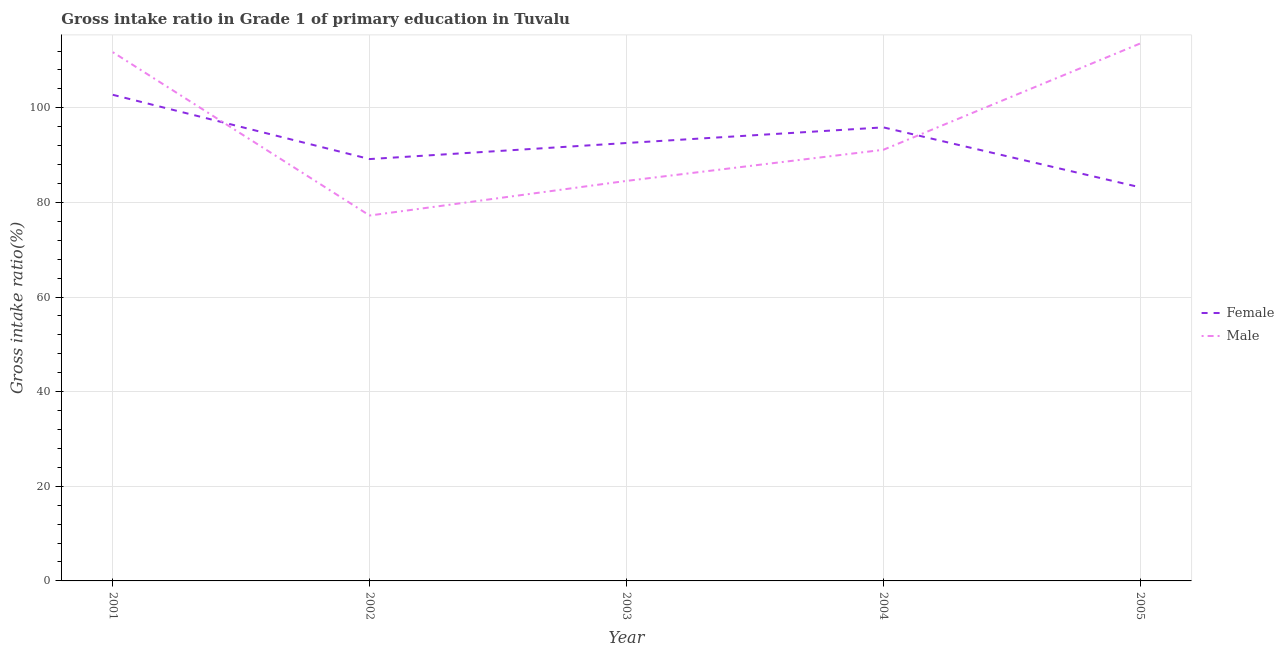How many different coloured lines are there?
Offer a very short reply. 2. Is the number of lines equal to the number of legend labels?
Keep it short and to the point. Yes. What is the gross intake ratio(female) in 2004?
Keep it short and to the point. 95.87. Across all years, what is the maximum gross intake ratio(female)?
Keep it short and to the point. 102.75. Across all years, what is the minimum gross intake ratio(female)?
Ensure brevity in your answer.  83.19. In which year was the gross intake ratio(male) maximum?
Give a very brief answer. 2005. In which year was the gross intake ratio(female) minimum?
Provide a succinct answer. 2005. What is the total gross intake ratio(male) in the graph?
Your answer should be compact. 478.28. What is the difference between the gross intake ratio(male) in 2001 and that in 2004?
Make the answer very short. 20.64. What is the difference between the gross intake ratio(male) in 2003 and the gross intake ratio(female) in 2002?
Keep it short and to the point. -4.61. What is the average gross intake ratio(female) per year?
Provide a succinct answer. 92.71. In the year 2005, what is the difference between the gross intake ratio(male) and gross intake ratio(female)?
Give a very brief answer. 30.41. What is the ratio of the gross intake ratio(female) in 2002 to that in 2003?
Your answer should be very brief. 0.96. Is the gross intake ratio(female) in 2002 less than that in 2003?
Your answer should be very brief. Yes. Is the difference between the gross intake ratio(male) in 2003 and 2004 greater than the difference between the gross intake ratio(female) in 2003 and 2004?
Make the answer very short. No. What is the difference between the highest and the second highest gross intake ratio(male)?
Provide a short and direct response. 1.84. What is the difference between the highest and the lowest gross intake ratio(male)?
Ensure brevity in your answer.  36.36. Is the sum of the gross intake ratio(female) in 2003 and 2005 greater than the maximum gross intake ratio(male) across all years?
Make the answer very short. Yes. Is the gross intake ratio(female) strictly greater than the gross intake ratio(male) over the years?
Keep it short and to the point. No. What is the difference between two consecutive major ticks on the Y-axis?
Keep it short and to the point. 20. Are the values on the major ticks of Y-axis written in scientific E-notation?
Give a very brief answer. No. Does the graph contain grids?
Make the answer very short. Yes. How many legend labels are there?
Provide a short and direct response. 2. What is the title of the graph?
Ensure brevity in your answer.  Gross intake ratio in Grade 1 of primary education in Tuvalu. Does "Merchandise exports" appear as one of the legend labels in the graph?
Offer a terse response. No. What is the label or title of the Y-axis?
Offer a terse response. Gross intake ratio(%). What is the Gross intake ratio(%) of Female in 2001?
Offer a very short reply. 102.75. What is the Gross intake ratio(%) of Male in 2001?
Keep it short and to the point. 111.76. What is the Gross intake ratio(%) of Female in 2002?
Your answer should be compact. 89.17. What is the Gross intake ratio(%) in Male in 2002?
Give a very brief answer. 77.24. What is the Gross intake ratio(%) in Female in 2003?
Offer a very short reply. 92.56. What is the Gross intake ratio(%) of Male in 2003?
Provide a succinct answer. 84.55. What is the Gross intake ratio(%) in Female in 2004?
Ensure brevity in your answer.  95.87. What is the Gross intake ratio(%) of Male in 2004?
Ensure brevity in your answer.  91.13. What is the Gross intake ratio(%) of Female in 2005?
Offer a very short reply. 83.19. What is the Gross intake ratio(%) in Male in 2005?
Your answer should be compact. 113.6. Across all years, what is the maximum Gross intake ratio(%) of Female?
Make the answer very short. 102.75. Across all years, what is the maximum Gross intake ratio(%) of Male?
Make the answer very short. 113.6. Across all years, what is the minimum Gross intake ratio(%) in Female?
Give a very brief answer. 83.19. Across all years, what is the minimum Gross intake ratio(%) of Male?
Provide a short and direct response. 77.24. What is the total Gross intake ratio(%) of Female in the graph?
Your answer should be compact. 463.54. What is the total Gross intake ratio(%) in Male in the graph?
Ensure brevity in your answer.  478.28. What is the difference between the Gross intake ratio(%) of Female in 2001 and that in 2002?
Make the answer very short. 13.59. What is the difference between the Gross intake ratio(%) of Male in 2001 and that in 2002?
Make the answer very short. 34.53. What is the difference between the Gross intake ratio(%) in Female in 2001 and that in 2003?
Provide a short and direct response. 10.19. What is the difference between the Gross intake ratio(%) in Male in 2001 and that in 2003?
Your response must be concise. 27.21. What is the difference between the Gross intake ratio(%) in Female in 2001 and that in 2004?
Ensure brevity in your answer.  6.88. What is the difference between the Gross intake ratio(%) in Male in 2001 and that in 2004?
Offer a terse response. 20.64. What is the difference between the Gross intake ratio(%) in Female in 2001 and that in 2005?
Make the answer very short. 19.56. What is the difference between the Gross intake ratio(%) of Male in 2001 and that in 2005?
Provide a succinct answer. -1.84. What is the difference between the Gross intake ratio(%) in Female in 2002 and that in 2003?
Provide a succinct answer. -3.4. What is the difference between the Gross intake ratio(%) of Male in 2002 and that in 2003?
Provide a short and direct response. -7.32. What is the difference between the Gross intake ratio(%) of Female in 2002 and that in 2004?
Provide a succinct answer. -6.7. What is the difference between the Gross intake ratio(%) of Male in 2002 and that in 2004?
Your answer should be compact. -13.89. What is the difference between the Gross intake ratio(%) in Female in 2002 and that in 2005?
Your answer should be very brief. 5.97. What is the difference between the Gross intake ratio(%) of Male in 2002 and that in 2005?
Keep it short and to the point. -36.36. What is the difference between the Gross intake ratio(%) in Female in 2003 and that in 2004?
Ensure brevity in your answer.  -3.31. What is the difference between the Gross intake ratio(%) of Male in 2003 and that in 2004?
Provide a succinct answer. -6.58. What is the difference between the Gross intake ratio(%) in Female in 2003 and that in 2005?
Keep it short and to the point. 9.37. What is the difference between the Gross intake ratio(%) in Male in 2003 and that in 2005?
Offer a terse response. -29.05. What is the difference between the Gross intake ratio(%) in Female in 2004 and that in 2005?
Offer a terse response. 12.67. What is the difference between the Gross intake ratio(%) of Male in 2004 and that in 2005?
Your answer should be very brief. -22.47. What is the difference between the Gross intake ratio(%) in Female in 2001 and the Gross intake ratio(%) in Male in 2002?
Your response must be concise. 25.52. What is the difference between the Gross intake ratio(%) in Female in 2001 and the Gross intake ratio(%) in Male in 2003?
Your response must be concise. 18.2. What is the difference between the Gross intake ratio(%) in Female in 2001 and the Gross intake ratio(%) in Male in 2004?
Provide a short and direct response. 11.62. What is the difference between the Gross intake ratio(%) in Female in 2001 and the Gross intake ratio(%) in Male in 2005?
Make the answer very short. -10.85. What is the difference between the Gross intake ratio(%) of Female in 2002 and the Gross intake ratio(%) of Male in 2003?
Keep it short and to the point. 4.61. What is the difference between the Gross intake ratio(%) of Female in 2002 and the Gross intake ratio(%) of Male in 2004?
Offer a very short reply. -1.96. What is the difference between the Gross intake ratio(%) in Female in 2002 and the Gross intake ratio(%) in Male in 2005?
Ensure brevity in your answer.  -24.43. What is the difference between the Gross intake ratio(%) in Female in 2003 and the Gross intake ratio(%) in Male in 2004?
Your response must be concise. 1.43. What is the difference between the Gross intake ratio(%) of Female in 2003 and the Gross intake ratio(%) of Male in 2005?
Your response must be concise. -21.04. What is the difference between the Gross intake ratio(%) of Female in 2004 and the Gross intake ratio(%) of Male in 2005?
Offer a very short reply. -17.73. What is the average Gross intake ratio(%) of Female per year?
Your response must be concise. 92.71. What is the average Gross intake ratio(%) of Male per year?
Your answer should be compact. 95.66. In the year 2001, what is the difference between the Gross intake ratio(%) in Female and Gross intake ratio(%) in Male?
Your answer should be very brief. -9.01. In the year 2002, what is the difference between the Gross intake ratio(%) of Female and Gross intake ratio(%) of Male?
Your response must be concise. 11.93. In the year 2003, what is the difference between the Gross intake ratio(%) in Female and Gross intake ratio(%) in Male?
Your answer should be compact. 8.01. In the year 2004, what is the difference between the Gross intake ratio(%) of Female and Gross intake ratio(%) of Male?
Offer a very short reply. 4.74. In the year 2005, what is the difference between the Gross intake ratio(%) in Female and Gross intake ratio(%) in Male?
Give a very brief answer. -30.41. What is the ratio of the Gross intake ratio(%) in Female in 2001 to that in 2002?
Offer a very short reply. 1.15. What is the ratio of the Gross intake ratio(%) of Male in 2001 to that in 2002?
Ensure brevity in your answer.  1.45. What is the ratio of the Gross intake ratio(%) in Female in 2001 to that in 2003?
Ensure brevity in your answer.  1.11. What is the ratio of the Gross intake ratio(%) of Male in 2001 to that in 2003?
Your answer should be very brief. 1.32. What is the ratio of the Gross intake ratio(%) of Female in 2001 to that in 2004?
Offer a very short reply. 1.07. What is the ratio of the Gross intake ratio(%) of Male in 2001 to that in 2004?
Keep it short and to the point. 1.23. What is the ratio of the Gross intake ratio(%) of Female in 2001 to that in 2005?
Keep it short and to the point. 1.24. What is the ratio of the Gross intake ratio(%) of Male in 2001 to that in 2005?
Provide a succinct answer. 0.98. What is the ratio of the Gross intake ratio(%) in Female in 2002 to that in 2003?
Ensure brevity in your answer.  0.96. What is the ratio of the Gross intake ratio(%) in Male in 2002 to that in 2003?
Your answer should be compact. 0.91. What is the ratio of the Gross intake ratio(%) of Female in 2002 to that in 2004?
Keep it short and to the point. 0.93. What is the ratio of the Gross intake ratio(%) in Male in 2002 to that in 2004?
Ensure brevity in your answer.  0.85. What is the ratio of the Gross intake ratio(%) in Female in 2002 to that in 2005?
Your response must be concise. 1.07. What is the ratio of the Gross intake ratio(%) of Male in 2002 to that in 2005?
Provide a short and direct response. 0.68. What is the ratio of the Gross intake ratio(%) of Female in 2003 to that in 2004?
Offer a terse response. 0.97. What is the ratio of the Gross intake ratio(%) in Male in 2003 to that in 2004?
Provide a short and direct response. 0.93. What is the ratio of the Gross intake ratio(%) of Female in 2003 to that in 2005?
Provide a short and direct response. 1.11. What is the ratio of the Gross intake ratio(%) in Male in 2003 to that in 2005?
Your answer should be very brief. 0.74. What is the ratio of the Gross intake ratio(%) in Female in 2004 to that in 2005?
Your answer should be very brief. 1.15. What is the ratio of the Gross intake ratio(%) in Male in 2004 to that in 2005?
Keep it short and to the point. 0.8. What is the difference between the highest and the second highest Gross intake ratio(%) in Female?
Your answer should be compact. 6.88. What is the difference between the highest and the second highest Gross intake ratio(%) in Male?
Provide a succinct answer. 1.84. What is the difference between the highest and the lowest Gross intake ratio(%) of Female?
Offer a terse response. 19.56. What is the difference between the highest and the lowest Gross intake ratio(%) in Male?
Keep it short and to the point. 36.36. 